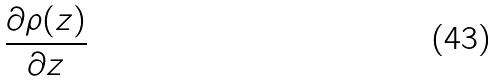Convert formula to latex. <formula><loc_0><loc_0><loc_500><loc_500>\frac { \partial \rho ( z ) } { \partial z }</formula> 